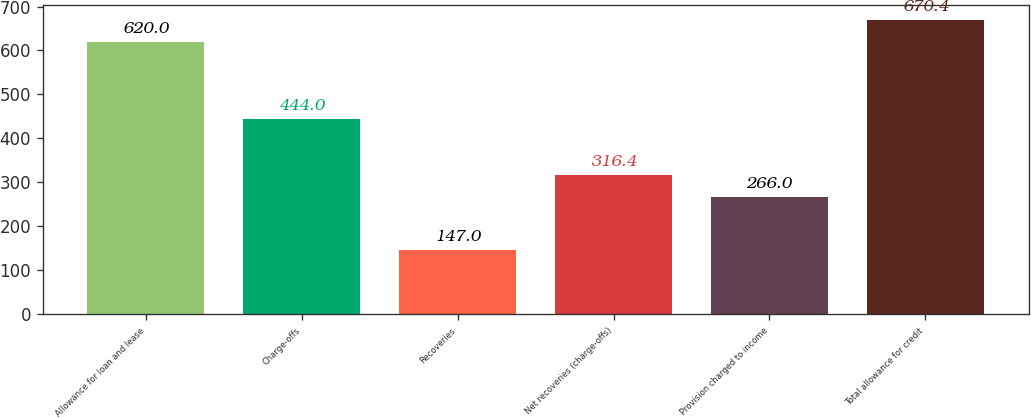Convert chart. <chart><loc_0><loc_0><loc_500><loc_500><bar_chart><fcel>Allowance for loan and lease<fcel>Charge-offs<fcel>Recoveries<fcel>Net recoveries (charge-offs)<fcel>Provision charged to income<fcel>Total allowance for credit<nl><fcel>620<fcel>444<fcel>147<fcel>316.4<fcel>266<fcel>670.4<nl></chart> 